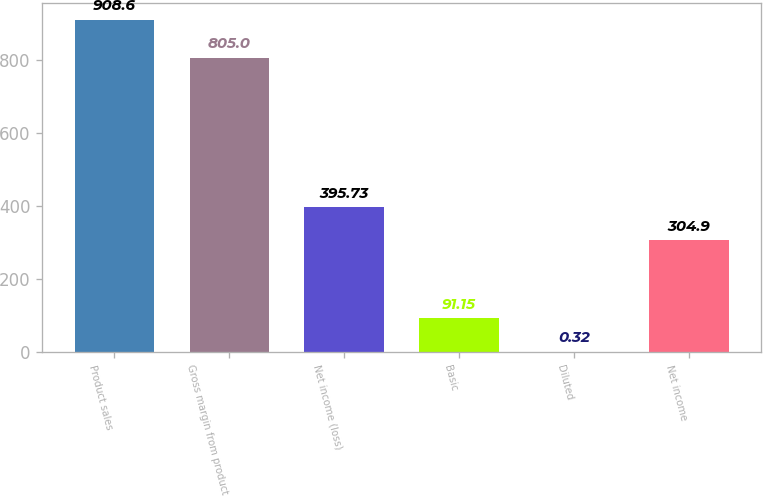Convert chart to OTSL. <chart><loc_0><loc_0><loc_500><loc_500><bar_chart><fcel>Product sales<fcel>Gross margin from product<fcel>Net income (loss)<fcel>Basic<fcel>Diluted<fcel>Net income<nl><fcel>908.6<fcel>805<fcel>395.73<fcel>91.15<fcel>0.32<fcel>304.9<nl></chart> 